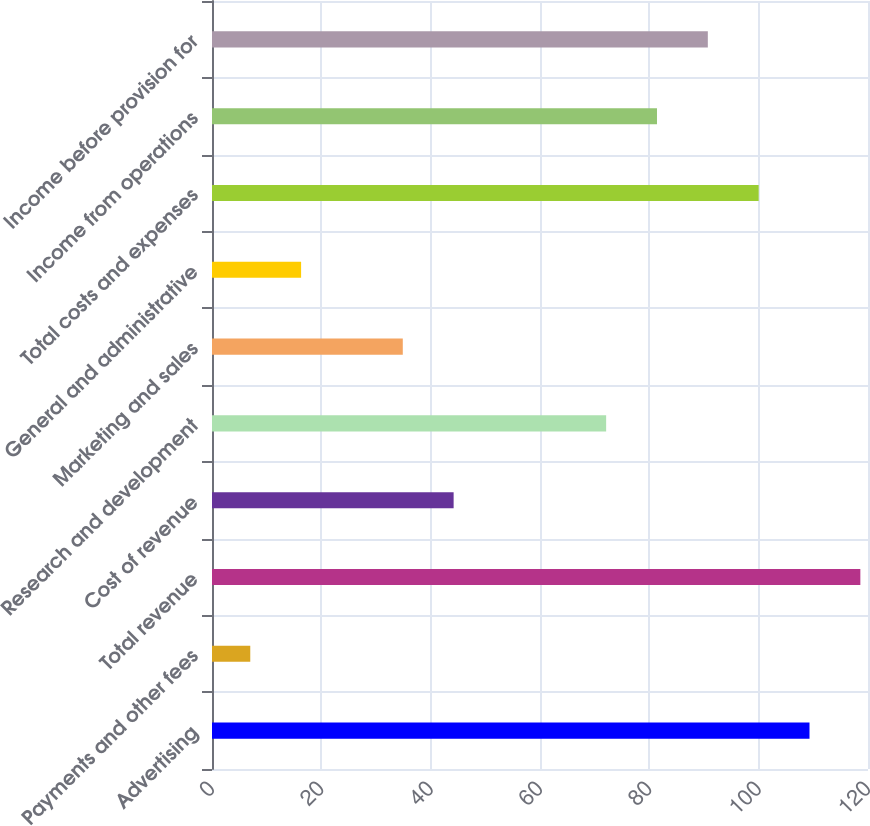Convert chart to OTSL. <chart><loc_0><loc_0><loc_500><loc_500><bar_chart><fcel>Advertising<fcel>Payments and other fees<fcel>Total revenue<fcel>Cost of revenue<fcel>Research and development<fcel>Marketing and sales<fcel>General and administrative<fcel>Total costs and expenses<fcel>Income from operations<fcel>Income before provision for<nl><fcel>109.3<fcel>7<fcel>118.6<fcel>44.2<fcel>72.1<fcel>34.9<fcel>16.3<fcel>100<fcel>81.4<fcel>90.7<nl></chart> 